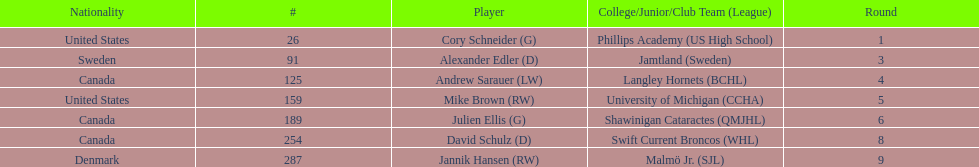The first round not to have a draft pick. 2. 